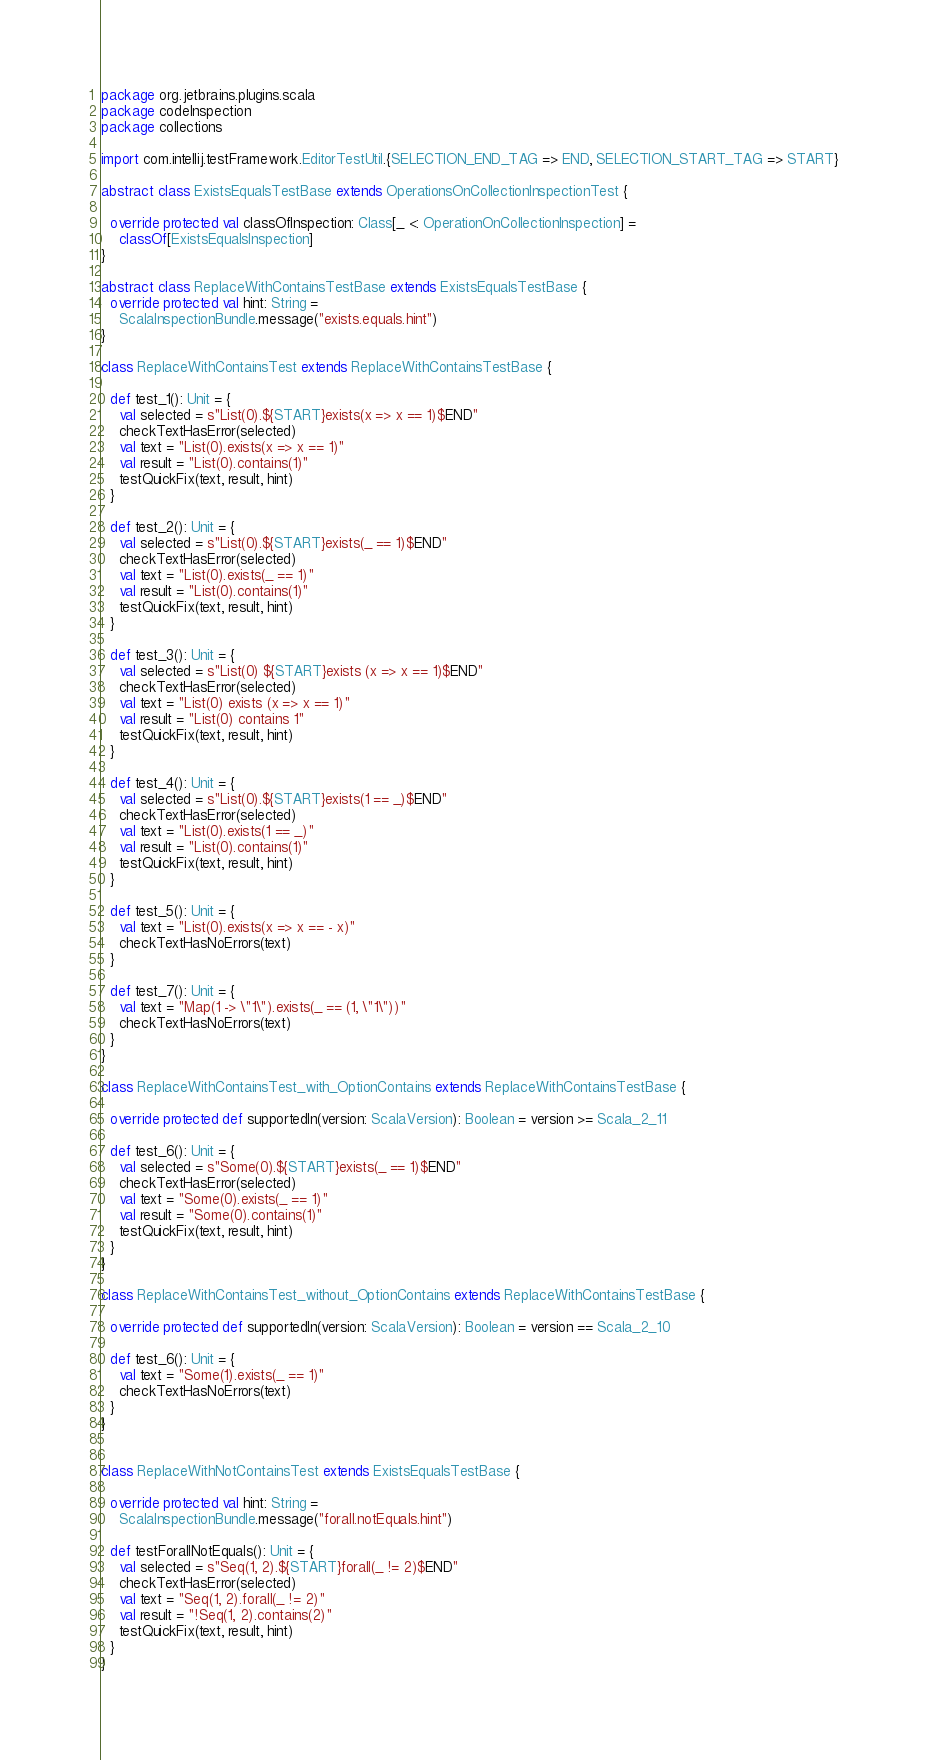Convert code to text. <code><loc_0><loc_0><loc_500><loc_500><_Scala_>package org.jetbrains.plugins.scala
package codeInspection
package collections

import com.intellij.testFramework.EditorTestUtil.{SELECTION_END_TAG => END, SELECTION_START_TAG => START}

abstract class ExistsEqualsTestBase extends OperationsOnCollectionInspectionTest {

  override protected val classOfInspection: Class[_ <: OperationOnCollectionInspection] =
    classOf[ExistsEqualsInspection]
}

abstract class ReplaceWithContainsTestBase extends ExistsEqualsTestBase {
  override protected val hint: String =
    ScalaInspectionBundle.message("exists.equals.hint")
}

class ReplaceWithContainsTest extends ReplaceWithContainsTestBase {

  def test_1(): Unit = {
    val selected = s"List(0).${START}exists(x => x == 1)$END"
    checkTextHasError(selected)
    val text = "List(0).exists(x => x == 1)"
    val result = "List(0).contains(1)"
    testQuickFix(text, result, hint)
  }

  def test_2(): Unit = {
    val selected = s"List(0).${START}exists(_ == 1)$END"
    checkTextHasError(selected)
    val text = "List(0).exists(_ == 1)"
    val result = "List(0).contains(1)"
    testQuickFix(text, result, hint)
  }

  def test_3(): Unit = {
    val selected = s"List(0) ${START}exists (x => x == 1)$END"
    checkTextHasError(selected)
    val text = "List(0) exists (x => x == 1)"
    val result = "List(0) contains 1"
    testQuickFix(text, result, hint)
  }

  def test_4(): Unit = {
    val selected = s"List(0).${START}exists(1 == _)$END"
    checkTextHasError(selected)
    val text = "List(0).exists(1 == _)"
    val result = "List(0).contains(1)"
    testQuickFix(text, result, hint)
  }

  def test_5(): Unit = {
    val text = "List(0).exists(x => x == - x)"
    checkTextHasNoErrors(text)
  }

  def test_7(): Unit = {
    val text = "Map(1 -> \"1\").exists(_ == (1, \"1\"))"
    checkTextHasNoErrors(text)
  }
}

class ReplaceWithContainsTest_with_OptionContains extends ReplaceWithContainsTestBase {

  override protected def supportedIn(version: ScalaVersion): Boolean = version >= Scala_2_11

  def test_6(): Unit = {
    val selected = s"Some(0).${START}exists(_ == 1)$END"
    checkTextHasError(selected)
    val text = "Some(0).exists(_ == 1)"
    val result = "Some(0).contains(1)"
    testQuickFix(text, result, hint)
  }
}

class ReplaceWithContainsTest_without_OptionContains extends ReplaceWithContainsTestBase {

  override protected def supportedIn(version: ScalaVersion): Boolean = version == Scala_2_10

  def test_6(): Unit = {
    val text = "Some(1).exists(_ == 1)"
    checkTextHasNoErrors(text)
  }
}


class ReplaceWithNotContainsTest extends ExistsEqualsTestBase {

  override protected val hint: String =
    ScalaInspectionBundle.message("forall.notEquals.hint")

  def testForallNotEquals(): Unit = {
    val selected = s"Seq(1, 2).${START}forall(_ != 2)$END"
    checkTextHasError(selected)
    val text = "Seq(1, 2).forall(_ != 2)"
    val result = "!Seq(1, 2).contains(2)"
    testQuickFix(text, result, hint)
  }
}
</code> 